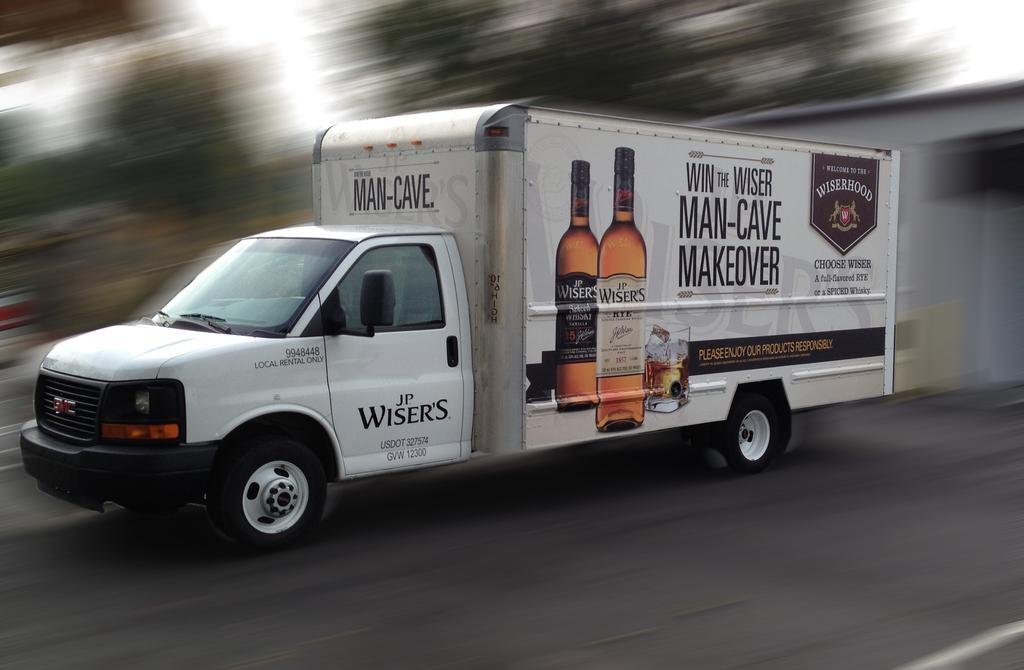Provide a one-sentence caption for the provided image. A J.P. Wisers truck with an image of Wiser bottles on the side of the truck. 